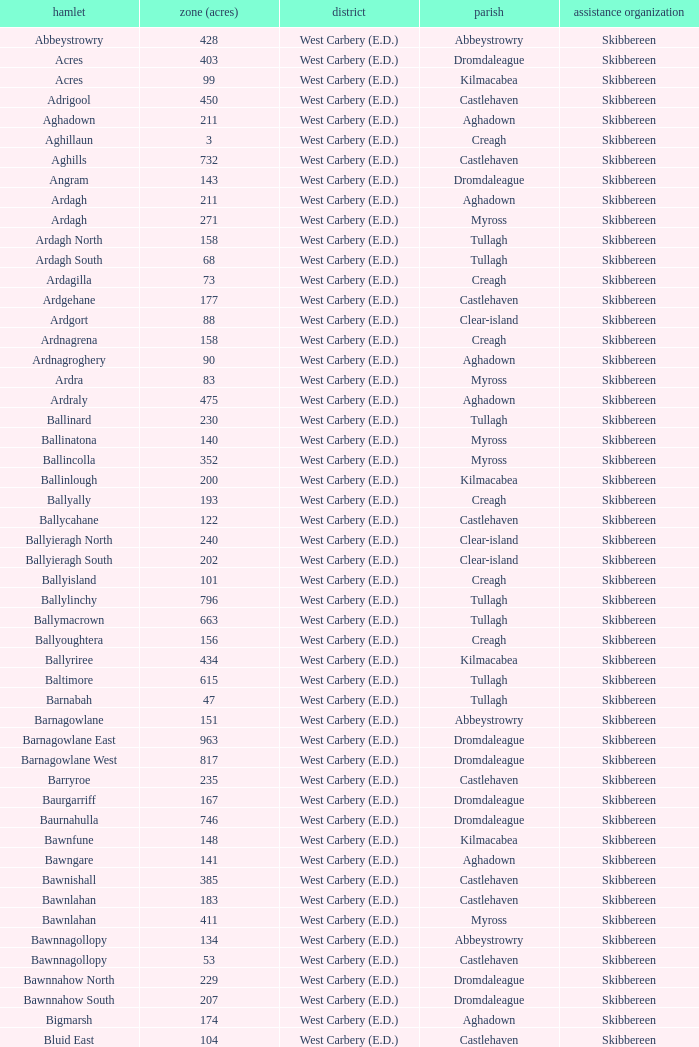What is the greatest area when the Poor Law Union is Skibbereen and the Civil Parish is Tullagh? 796.0. 